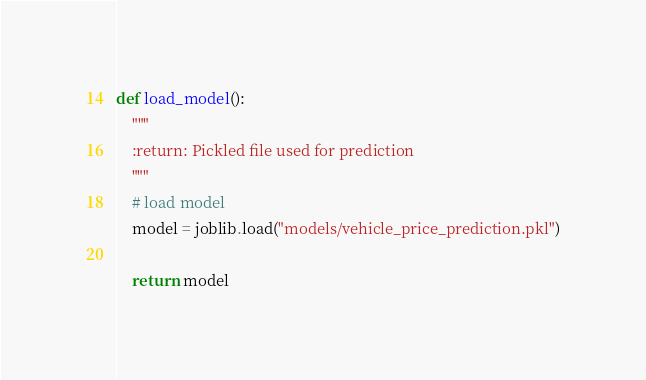<code> <loc_0><loc_0><loc_500><loc_500><_Python_>
def load_model():
    """
    :return: Pickled file used for prediction
    """
    # load model
    model = joblib.load("models/vehicle_price_prediction.pkl")

    return model</code> 